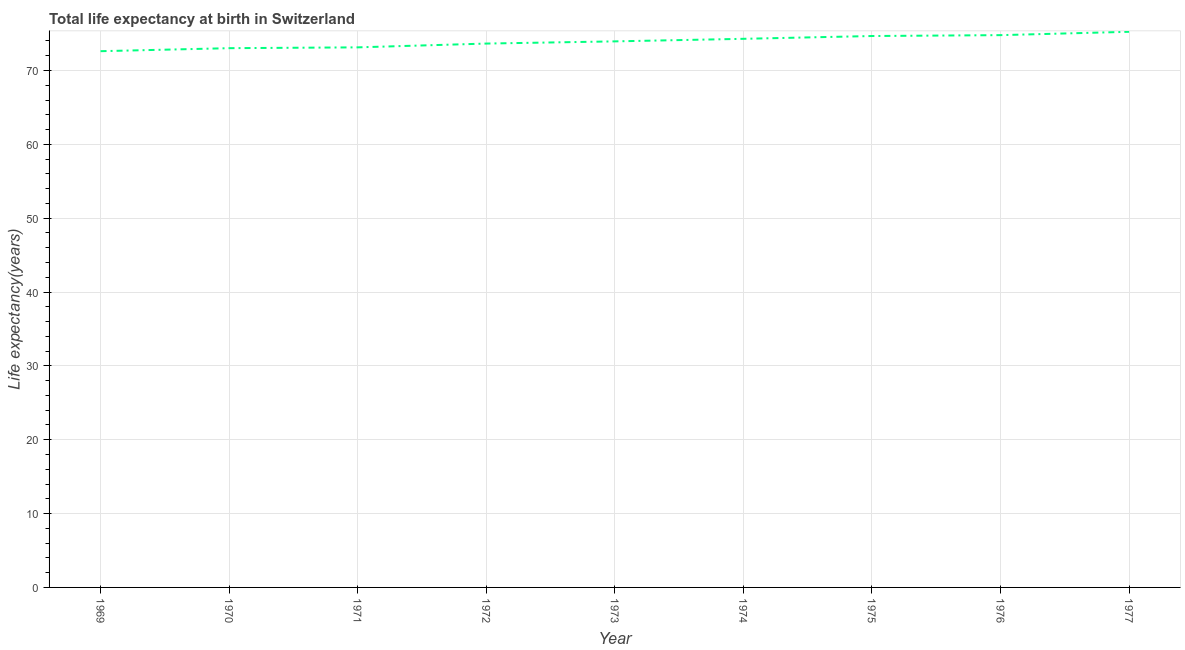What is the life expectancy at birth in 1974?
Offer a very short reply. 74.29. Across all years, what is the maximum life expectancy at birth?
Your answer should be very brief. 75.24. Across all years, what is the minimum life expectancy at birth?
Make the answer very short. 72.61. In which year was the life expectancy at birth minimum?
Your answer should be compact. 1969. What is the sum of the life expectancy at birth?
Your answer should be compact. 665.33. What is the difference between the life expectancy at birth in 1969 and 1970?
Keep it short and to the point. -0.41. What is the average life expectancy at birth per year?
Your answer should be compact. 73.93. What is the median life expectancy at birth?
Provide a short and direct response. 73.94. In how many years, is the life expectancy at birth greater than 56 years?
Your response must be concise. 9. What is the ratio of the life expectancy at birth in 1972 to that in 1975?
Offer a terse response. 0.99. Is the difference between the life expectancy at birth in 1970 and 1975 greater than the difference between any two years?
Your answer should be very brief. No. What is the difference between the highest and the second highest life expectancy at birth?
Give a very brief answer. 0.45. Is the sum of the life expectancy at birth in 1969 and 1972 greater than the maximum life expectancy at birth across all years?
Ensure brevity in your answer.  Yes. What is the difference between the highest and the lowest life expectancy at birth?
Offer a very short reply. 2.63. In how many years, is the life expectancy at birth greater than the average life expectancy at birth taken over all years?
Your answer should be very brief. 5. How many lines are there?
Make the answer very short. 1. How many years are there in the graph?
Provide a succinct answer. 9. What is the difference between two consecutive major ticks on the Y-axis?
Provide a short and direct response. 10. Are the values on the major ticks of Y-axis written in scientific E-notation?
Your answer should be compact. No. Does the graph contain grids?
Provide a short and direct response. Yes. What is the title of the graph?
Your answer should be very brief. Total life expectancy at birth in Switzerland. What is the label or title of the X-axis?
Provide a succinct answer. Year. What is the label or title of the Y-axis?
Provide a succinct answer. Life expectancy(years). What is the Life expectancy(years) of 1969?
Give a very brief answer. 72.61. What is the Life expectancy(years) of 1970?
Keep it short and to the point. 73.02. What is the Life expectancy(years) in 1971?
Provide a succinct answer. 73.13. What is the Life expectancy(years) of 1972?
Offer a terse response. 73.64. What is the Life expectancy(years) in 1973?
Your response must be concise. 73.94. What is the Life expectancy(years) in 1974?
Provide a short and direct response. 74.29. What is the Life expectancy(years) in 1975?
Offer a terse response. 74.67. What is the Life expectancy(years) of 1976?
Make the answer very short. 74.79. What is the Life expectancy(years) in 1977?
Make the answer very short. 75.24. What is the difference between the Life expectancy(years) in 1969 and 1970?
Your answer should be very brief. -0.41. What is the difference between the Life expectancy(years) in 1969 and 1971?
Provide a short and direct response. -0.52. What is the difference between the Life expectancy(years) in 1969 and 1972?
Give a very brief answer. -1.03. What is the difference between the Life expectancy(years) in 1969 and 1973?
Offer a terse response. -1.33. What is the difference between the Life expectancy(years) in 1969 and 1974?
Provide a succinct answer. -1.67. What is the difference between the Life expectancy(years) in 1969 and 1975?
Offer a terse response. -2.05. What is the difference between the Life expectancy(years) in 1969 and 1976?
Provide a short and direct response. -2.17. What is the difference between the Life expectancy(years) in 1969 and 1977?
Your answer should be very brief. -2.63. What is the difference between the Life expectancy(years) in 1970 and 1971?
Give a very brief answer. -0.11. What is the difference between the Life expectancy(years) in 1970 and 1972?
Make the answer very short. -0.62. What is the difference between the Life expectancy(years) in 1970 and 1973?
Offer a very short reply. -0.92. What is the difference between the Life expectancy(years) in 1970 and 1974?
Provide a succinct answer. -1.27. What is the difference between the Life expectancy(years) in 1970 and 1975?
Provide a short and direct response. -1.65. What is the difference between the Life expectancy(years) in 1970 and 1976?
Your answer should be compact. -1.77. What is the difference between the Life expectancy(years) in 1970 and 1977?
Provide a short and direct response. -2.22. What is the difference between the Life expectancy(years) in 1971 and 1972?
Ensure brevity in your answer.  -0.51. What is the difference between the Life expectancy(years) in 1971 and 1973?
Keep it short and to the point. -0.81. What is the difference between the Life expectancy(years) in 1971 and 1974?
Your answer should be very brief. -1.16. What is the difference between the Life expectancy(years) in 1971 and 1975?
Keep it short and to the point. -1.53. What is the difference between the Life expectancy(years) in 1971 and 1976?
Make the answer very short. -1.65. What is the difference between the Life expectancy(years) in 1971 and 1977?
Give a very brief answer. -2.11. What is the difference between the Life expectancy(years) in 1972 and 1973?
Your response must be concise. -0.3. What is the difference between the Life expectancy(years) in 1972 and 1974?
Your answer should be compact. -0.64. What is the difference between the Life expectancy(years) in 1972 and 1975?
Offer a very short reply. -1.02. What is the difference between the Life expectancy(years) in 1972 and 1976?
Ensure brevity in your answer.  -1.14. What is the difference between the Life expectancy(years) in 1972 and 1977?
Ensure brevity in your answer.  -1.59. What is the difference between the Life expectancy(years) in 1973 and 1974?
Your answer should be very brief. -0.35. What is the difference between the Life expectancy(years) in 1973 and 1975?
Make the answer very short. -0.72. What is the difference between the Life expectancy(years) in 1973 and 1976?
Provide a short and direct response. -0.84. What is the difference between the Life expectancy(years) in 1973 and 1977?
Give a very brief answer. -1.3. What is the difference between the Life expectancy(years) in 1974 and 1975?
Offer a very short reply. -0.38. What is the difference between the Life expectancy(years) in 1974 and 1976?
Provide a succinct answer. -0.5. What is the difference between the Life expectancy(years) in 1974 and 1977?
Offer a very short reply. -0.95. What is the difference between the Life expectancy(years) in 1975 and 1976?
Keep it short and to the point. -0.12. What is the difference between the Life expectancy(years) in 1975 and 1977?
Your response must be concise. -0.57. What is the difference between the Life expectancy(years) in 1976 and 1977?
Your response must be concise. -0.45. What is the ratio of the Life expectancy(years) in 1969 to that in 1970?
Give a very brief answer. 0.99. What is the ratio of the Life expectancy(years) in 1969 to that in 1973?
Keep it short and to the point. 0.98. What is the ratio of the Life expectancy(years) in 1969 to that in 1974?
Your answer should be very brief. 0.98. What is the ratio of the Life expectancy(years) in 1969 to that in 1975?
Make the answer very short. 0.97. What is the ratio of the Life expectancy(years) in 1969 to that in 1977?
Provide a succinct answer. 0.96. What is the ratio of the Life expectancy(years) in 1970 to that in 1973?
Keep it short and to the point. 0.99. What is the ratio of the Life expectancy(years) in 1970 to that in 1974?
Keep it short and to the point. 0.98. What is the ratio of the Life expectancy(years) in 1971 to that in 1972?
Make the answer very short. 0.99. What is the ratio of the Life expectancy(years) in 1971 to that in 1973?
Offer a terse response. 0.99. What is the ratio of the Life expectancy(years) in 1971 to that in 1976?
Ensure brevity in your answer.  0.98. What is the ratio of the Life expectancy(years) in 1972 to that in 1973?
Your answer should be very brief. 1. What is the ratio of the Life expectancy(years) in 1972 to that in 1974?
Keep it short and to the point. 0.99. What is the ratio of the Life expectancy(years) in 1972 to that in 1976?
Ensure brevity in your answer.  0.98. What is the ratio of the Life expectancy(years) in 1973 to that in 1976?
Offer a very short reply. 0.99. What is the ratio of the Life expectancy(years) in 1973 to that in 1977?
Offer a terse response. 0.98. What is the ratio of the Life expectancy(years) in 1974 to that in 1975?
Provide a short and direct response. 0.99. What is the ratio of the Life expectancy(years) in 1976 to that in 1977?
Provide a succinct answer. 0.99. 